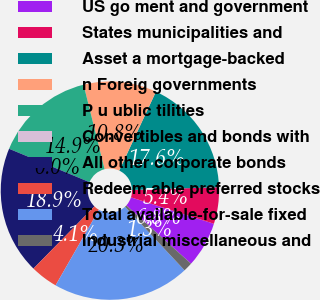Convert chart. <chart><loc_0><loc_0><loc_500><loc_500><pie_chart><fcel>US go ment and government<fcel>States municipalities and<fcel>Asset a mortgage-backed<fcel>n Foreig governments<fcel>P u ublic tilities<fcel>Convertibles and bonds with<fcel>All other corporate bonds<fcel>Redeem able preferred stocks<fcel>Total available-for-sale fixed<fcel>Industrial miscellaneous and<nl><fcel>6.76%<fcel>5.41%<fcel>17.57%<fcel>10.81%<fcel>14.86%<fcel>0.0%<fcel>18.92%<fcel>4.06%<fcel>20.27%<fcel>1.35%<nl></chart> 